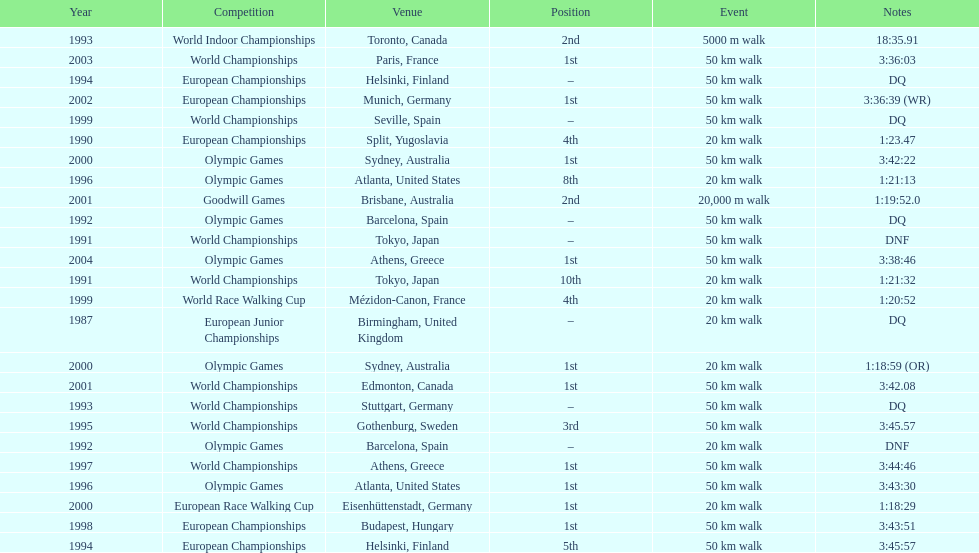How many times did korzeniowski finish above fourth place? 13. 